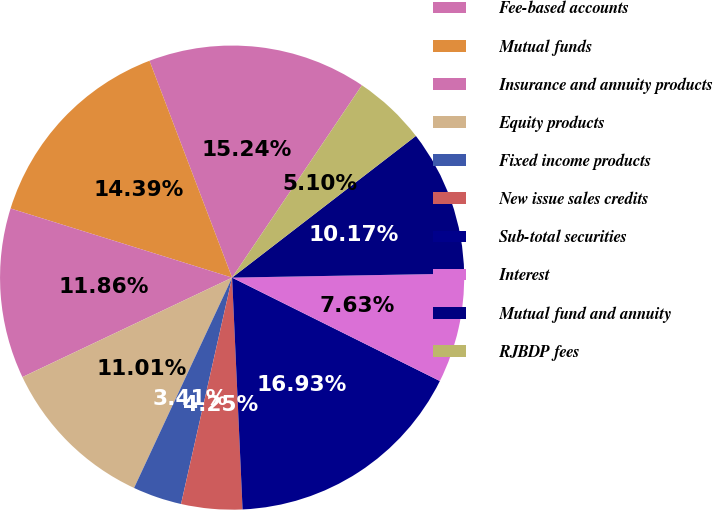Convert chart. <chart><loc_0><loc_0><loc_500><loc_500><pie_chart><fcel>Fee-based accounts<fcel>Mutual funds<fcel>Insurance and annuity products<fcel>Equity products<fcel>Fixed income products<fcel>New issue sales credits<fcel>Sub-total securities<fcel>Interest<fcel>Mutual fund and annuity<fcel>RJBDP fees<nl><fcel>15.24%<fcel>14.39%<fcel>11.86%<fcel>11.01%<fcel>3.41%<fcel>4.25%<fcel>16.93%<fcel>7.63%<fcel>10.17%<fcel>5.1%<nl></chart> 